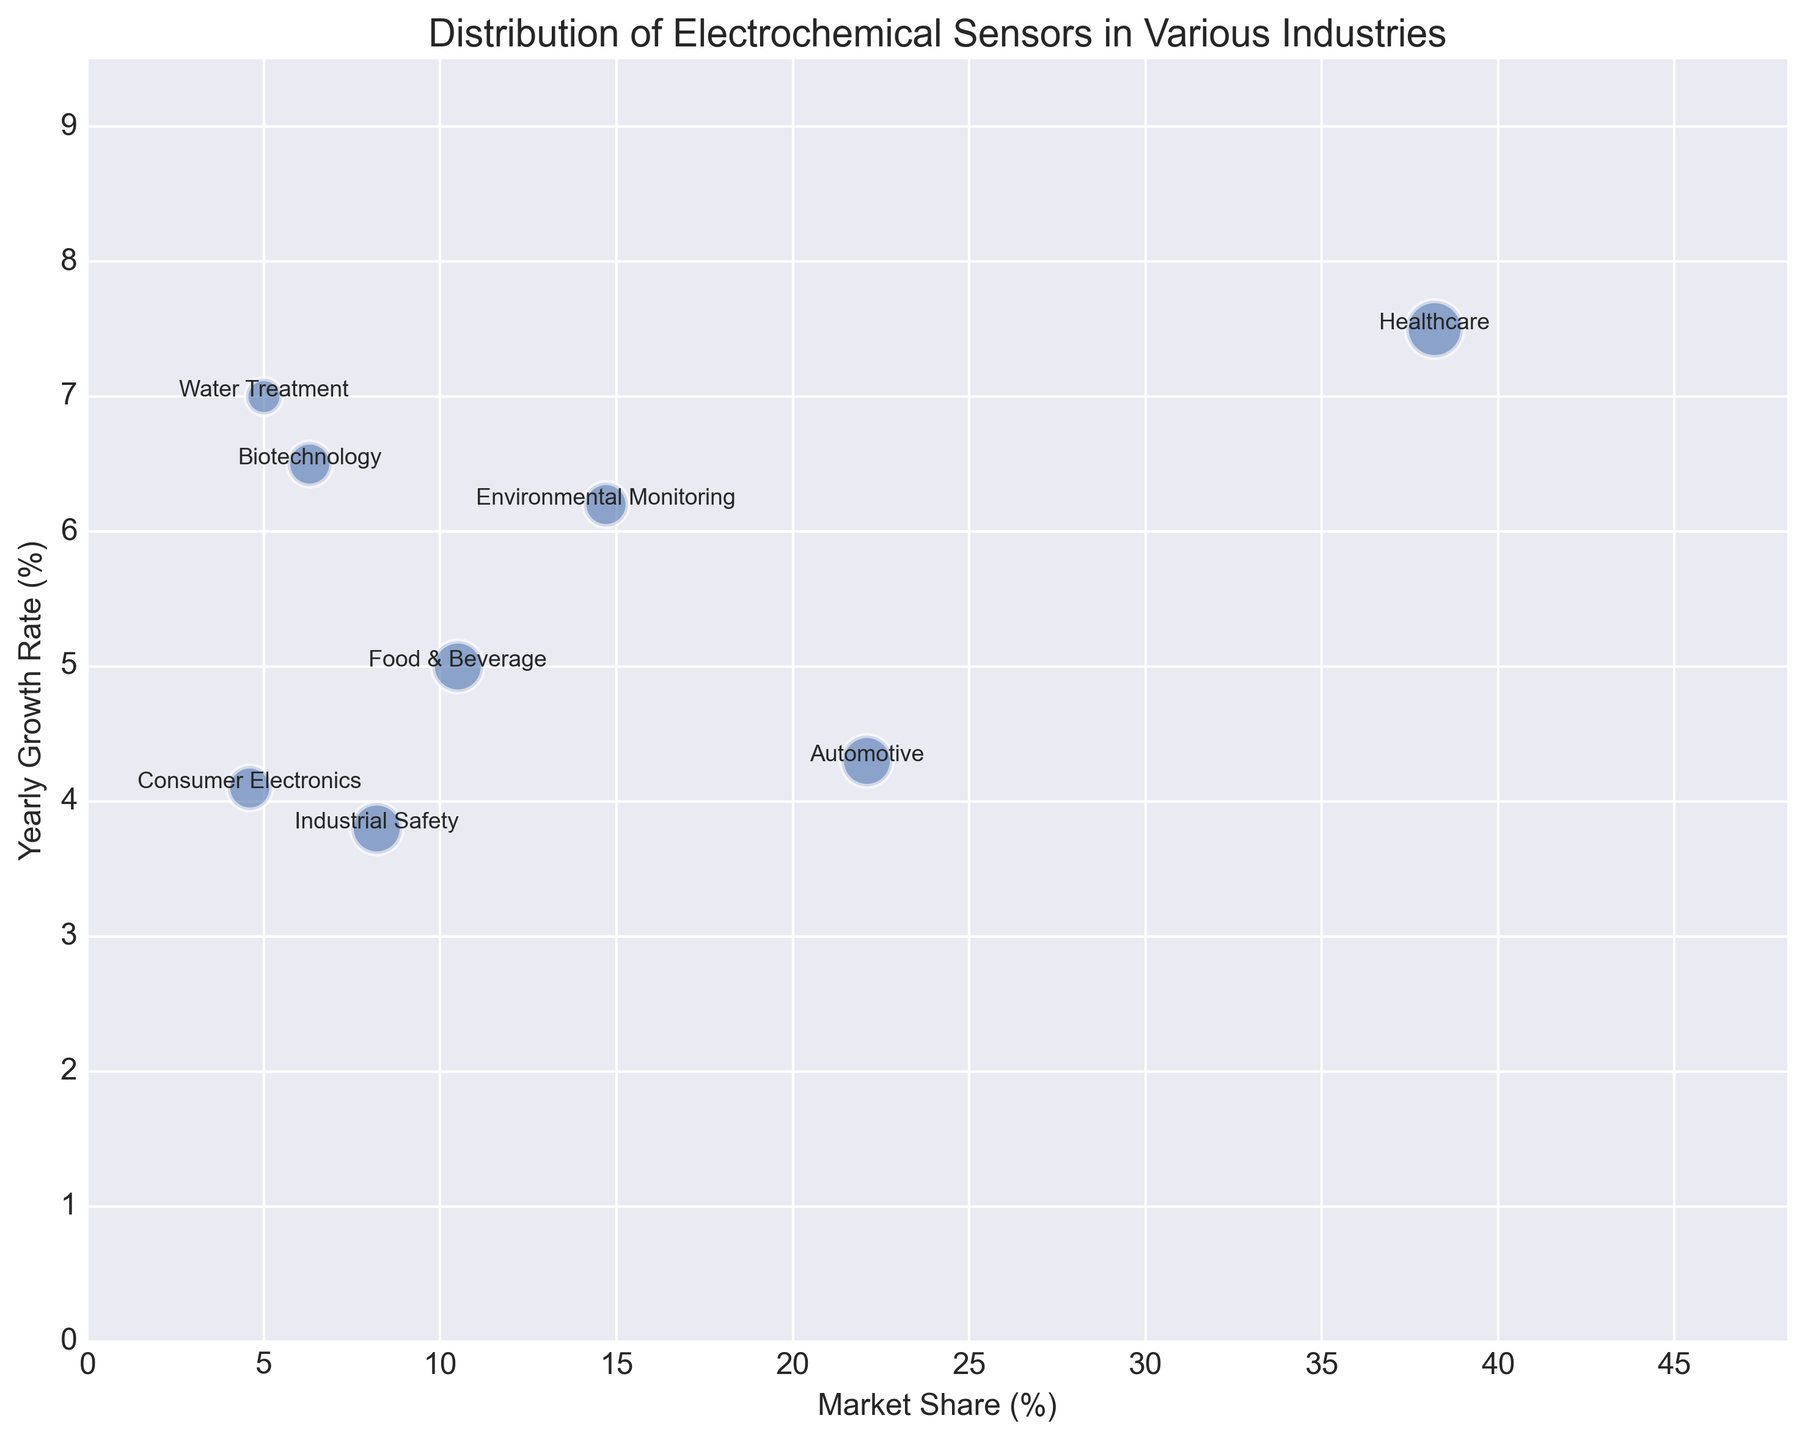Which industry uses Biosensors and what are their market share and yearly growth rate? The label "Healthcare" is associated with Biosensors on the plot. The x-axis value for Biosensors is 38.2%, indicating the market share, and the y-axis value is 7.5%, indicating the yearly growth rate.
Answer: Healthcare, 38.2%, 7.5% Which type of sensor is used in the Automotive industry and what is its market share? The label "Automotive" is associated with Electrochemical Gas Sensors on the plot. The x-axis value for Electrochemical Gas Sensors is 22.1%, indicating the market share.
Answer: Electrochemical Gas Sensors, 22.1% Among all the sensor types, which one has the highest yearly growth rate and in which industry is it used? The highest point on the y-axis is 7.5%, associated with Biosensors. The label "Healthcare" is adjacent to this point.
Answer: Biosensors, Healthcare What is the combined market share of sensors used in Industrial Safety and Water Treatment industries? The market share for Potenziometric Sensors (Industrial Safety) is 8.2%, and for Voltammetric Sensors (Water Treatment) is 5%. Adding these values: 8.2 + 5 = 13.2%.
Answer: 13.2% Which industry uses sensors with both a medium-sized bubble and an above-average yearly growth rate? Medium-sized bubbles correspond to importance values of around 4. The label "Healthcare" associated with a 5 importance value and a 7.5% growth rate, meets these criteria.
Answer: Healthcare Which type of sensor has the lowest market share and what is its yearly growth rate? The smallest x-axis value is 4.6%, associated with Resistive Sensors in the Consumer Electronics industry. The y-axis value for this point indicates a 4.1% yearly growth rate.
Answer: Resistive Sensors, 4.1% How much larger is the market share of Biosensors compared to Potenziometric Sensors? The market share for Biosensors is 38.2% and for Potenziometric Sensors is 8.2%. The difference is calculated as 38.2 - 8.2 = 30%.
Answer: 30% Which industry uses Conductometric Sensors and how does their yearly growth rate compare to that of Impedimetric Sensors? Conductometric Sensors are used in Environmental Monitoring with a yearly growth rate of 6.2%. Impedimetric Sensors in Biotechnology have a growth rate of 6.5%. Comparing, 6.2 < 6.5.
Answer: Environmental Monitoring, 6.2% < 6.5% Which two sensor types have the closest yearly growth rates and what are the industries they are used in? The growth rates of 6.2% and 6.5% are closest, associated with Conductometric Sensors (Environmental Monitoring) and Impedimetric Sensors (Biotechnology), respectively.
Answer: Conductometric Sensors (Environmental Monitoring), Impedimetric Sensors (Biotechnology) 